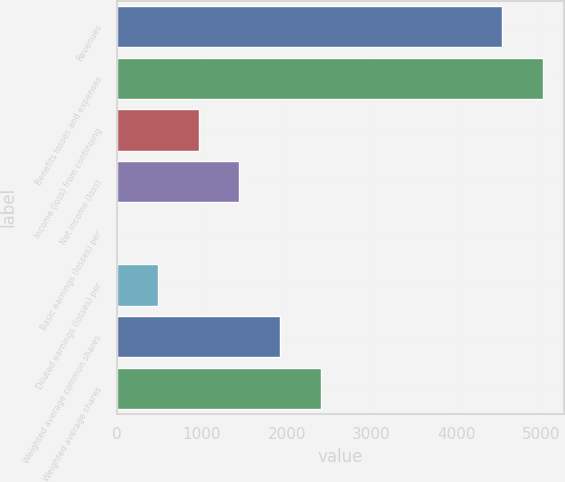Convert chart. <chart><loc_0><loc_0><loc_500><loc_500><bar_chart><fcel>Revenues<fcel>Benefits losses and expenses<fcel>Income (loss) from continuing<fcel>Net income (loss)<fcel>Basic earnings (losses) per<fcel>Diluted earnings (losses) per<fcel>Weighted average common shares<fcel>Weighted average shares<nl><fcel>4537<fcel>5018.18<fcel>962.58<fcel>1443.76<fcel>0.22<fcel>481.4<fcel>1924.94<fcel>2406.12<nl></chart> 